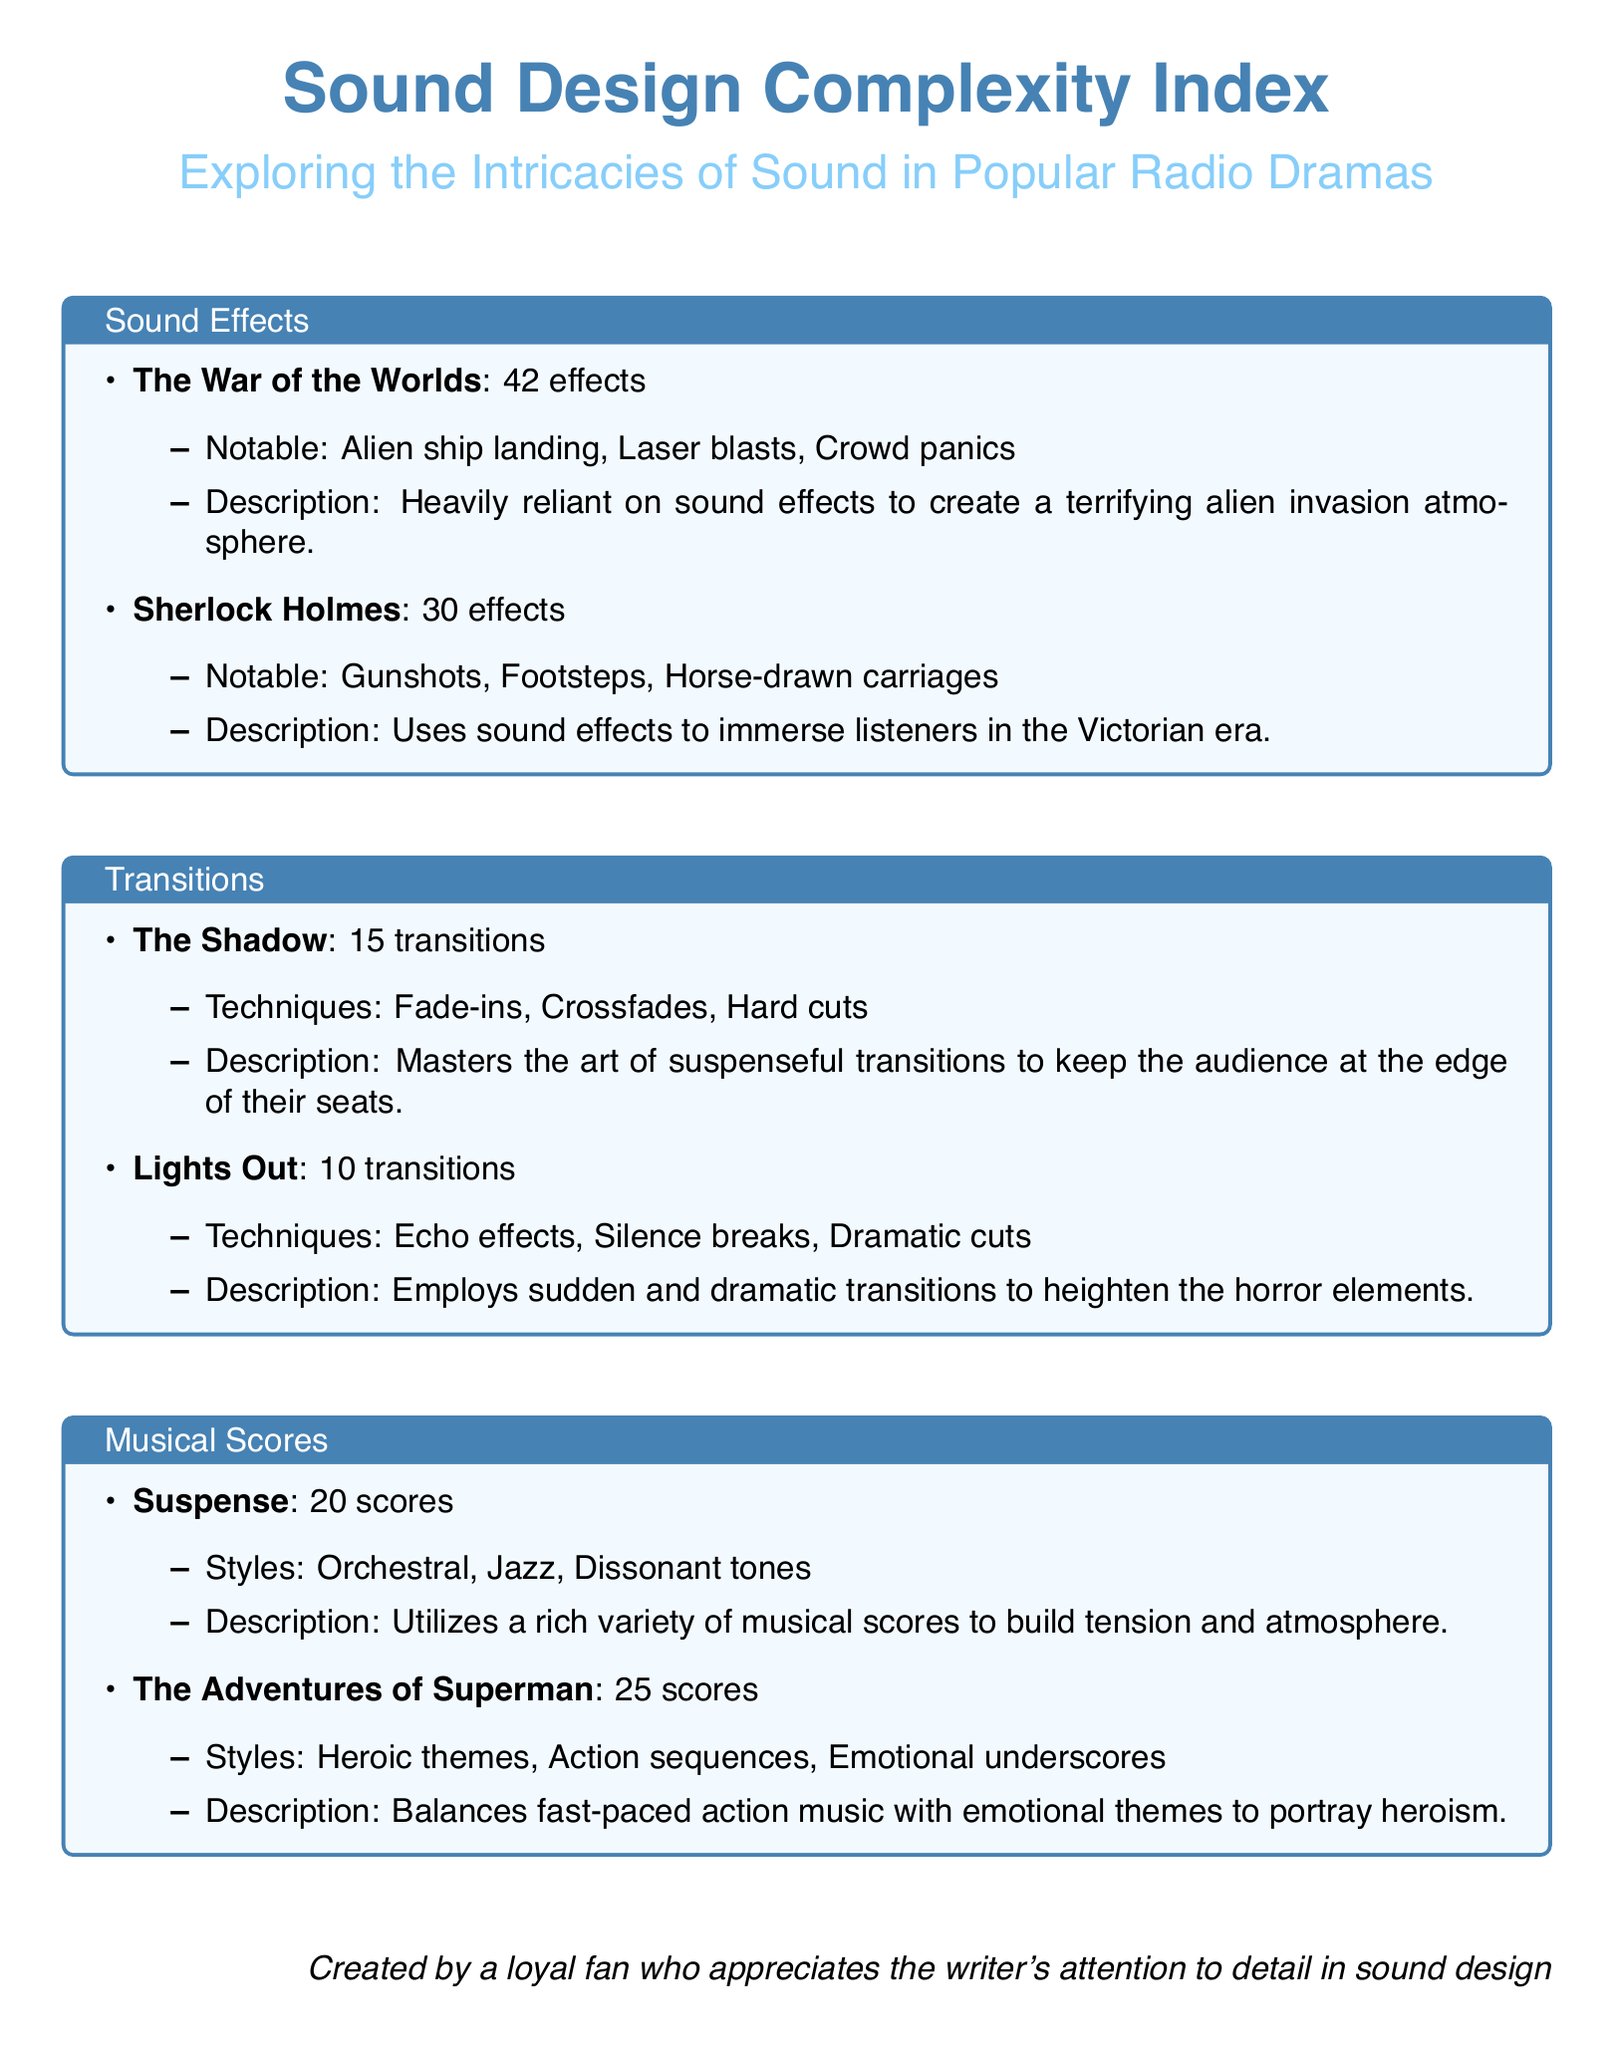What is the total number of sound effects used in "The War of the Worlds"? The total number of sound effects is specified in the document under the sound effects section for "The War of the Worlds", which states 42 effects.
Answer: 42 effects How many transitions does "The Shadow" employ? The number of transitions is mentioned in the document, specifically stating that "The Shadow" employs 15 transitions.
Answer: 15 transitions What notable sound effects are used in "Sherlock Holmes"? The notable sound effects for "Sherlock Holmes" are listed in the document as gunshots, footsteps, and horse-drawn carriages.
Answer: Gunshots, footsteps, horse-drawn carriages How many musical scores does "The Adventures of Superman" have? The document states that "The Adventures of Superman" has 25 musical scores.
Answer: 25 scores Which radio drama uses echo effects and silence breaks in its transitions? The document specifies that "Lights Out" employs echo effects and silence breaks in its transitions.
Answer: Lights Out What style of musical score is used in "Suspense"? The document indicates that "Suspense" utilizes orchestral, jazz, and dissonant tones in its musical scores.
Answer: Orchestral, jazz, dissonant tones Which radio drama has the highest number of sound effects? According to the document, "The War of the Worlds" has the highest number of sound effects at 42.
Answer: The War of the Worlds What techniques are used for transitions in "Lights Out"? The document states that "Lights Out" employs echo effects, silence breaks, and dramatic cuts for its transitions.
Answer: Echo effects, silence breaks, dramatic cuts 